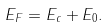Convert formula to latex. <formula><loc_0><loc_0><loc_500><loc_500>E _ { F } = E _ { c } + E _ { 0 } .</formula> 